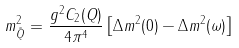Convert formula to latex. <formula><loc_0><loc_0><loc_500><loc_500>m ^ { 2 } _ { \tilde { Q } } = \frac { g ^ { 2 } C _ { 2 } ( Q ) } { 4 \pi ^ { 4 } } \left [ \Delta m ^ { 2 } ( 0 ) - \Delta m ^ { 2 } ( \omega ) \right ]</formula> 